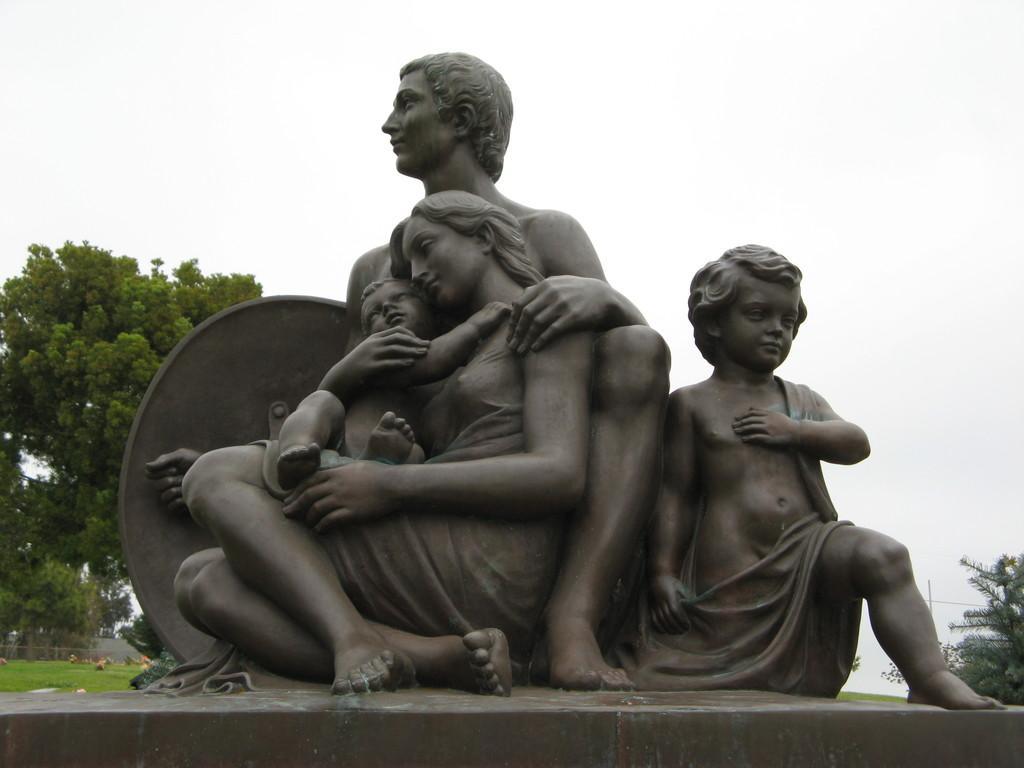Could you give a brief overview of what you see in this image? Here we can see statues. Background there are trees, grass and sky. 